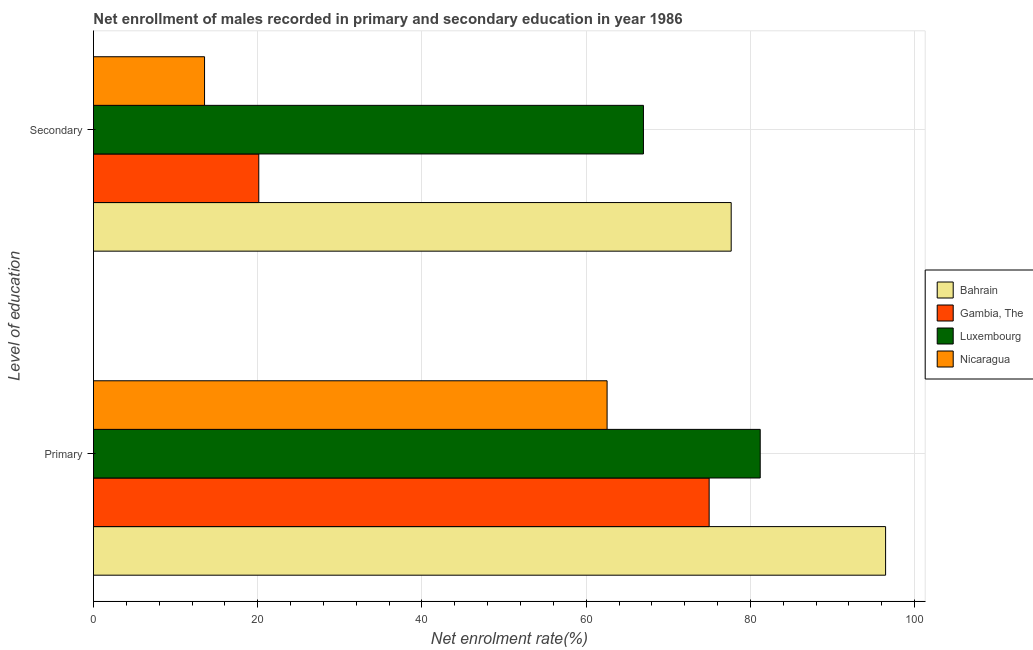How many different coloured bars are there?
Provide a succinct answer. 4. How many groups of bars are there?
Keep it short and to the point. 2. Are the number of bars per tick equal to the number of legend labels?
Your response must be concise. Yes. Are the number of bars on each tick of the Y-axis equal?
Offer a terse response. Yes. What is the label of the 1st group of bars from the top?
Give a very brief answer. Secondary. What is the enrollment rate in secondary education in Nicaragua?
Give a very brief answer. 13.53. Across all countries, what is the maximum enrollment rate in secondary education?
Your answer should be very brief. 77.66. Across all countries, what is the minimum enrollment rate in primary education?
Your answer should be compact. 62.55. In which country was the enrollment rate in primary education maximum?
Keep it short and to the point. Bahrain. In which country was the enrollment rate in primary education minimum?
Provide a succinct answer. Nicaragua. What is the total enrollment rate in primary education in the graph?
Offer a terse response. 315.2. What is the difference between the enrollment rate in primary education in Nicaragua and that in Bahrain?
Make the answer very short. -33.92. What is the difference between the enrollment rate in secondary education in Bahrain and the enrollment rate in primary education in Nicaragua?
Offer a terse response. 15.11. What is the average enrollment rate in primary education per country?
Provide a short and direct response. 78.8. What is the difference between the enrollment rate in primary education and enrollment rate in secondary education in Bahrain?
Provide a short and direct response. 18.8. What is the ratio of the enrollment rate in secondary education in Luxembourg to that in Nicaragua?
Your answer should be compact. 4.95. In how many countries, is the enrollment rate in secondary education greater than the average enrollment rate in secondary education taken over all countries?
Your answer should be compact. 2. What does the 2nd bar from the top in Secondary represents?
Ensure brevity in your answer.  Luxembourg. What does the 3rd bar from the bottom in Secondary represents?
Give a very brief answer. Luxembourg. What is the difference between two consecutive major ticks on the X-axis?
Provide a succinct answer. 20. Where does the legend appear in the graph?
Keep it short and to the point. Center right. How many legend labels are there?
Ensure brevity in your answer.  4. What is the title of the graph?
Ensure brevity in your answer.  Net enrollment of males recorded in primary and secondary education in year 1986. Does "Micronesia" appear as one of the legend labels in the graph?
Your response must be concise. No. What is the label or title of the X-axis?
Offer a terse response. Net enrolment rate(%). What is the label or title of the Y-axis?
Provide a short and direct response. Level of education. What is the Net enrolment rate(%) in Bahrain in Primary?
Ensure brevity in your answer.  96.47. What is the Net enrolment rate(%) of Gambia, The in Primary?
Make the answer very short. 74.98. What is the Net enrolment rate(%) of Luxembourg in Primary?
Your answer should be very brief. 81.2. What is the Net enrolment rate(%) of Nicaragua in Primary?
Offer a very short reply. 62.55. What is the Net enrolment rate(%) of Bahrain in Secondary?
Your answer should be very brief. 77.66. What is the Net enrolment rate(%) in Gambia, The in Secondary?
Give a very brief answer. 20.13. What is the Net enrolment rate(%) in Luxembourg in Secondary?
Offer a very short reply. 66.98. What is the Net enrolment rate(%) of Nicaragua in Secondary?
Your response must be concise. 13.53. Across all Level of education, what is the maximum Net enrolment rate(%) of Bahrain?
Make the answer very short. 96.47. Across all Level of education, what is the maximum Net enrolment rate(%) in Gambia, The?
Your answer should be very brief. 74.98. Across all Level of education, what is the maximum Net enrolment rate(%) of Luxembourg?
Your answer should be compact. 81.2. Across all Level of education, what is the maximum Net enrolment rate(%) of Nicaragua?
Provide a succinct answer. 62.55. Across all Level of education, what is the minimum Net enrolment rate(%) of Bahrain?
Offer a terse response. 77.66. Across all Level of education, what is the minimum Net enrolment rate(%) in Gambia, The?
Your answer should be compact. 20.13. Across all Level of education, what is the minimum Net enrolment rate(%) in Luxembourg?
Keep it short and to the point. 66.98. Across all Level of education, what is the minimum Net enrolment rate(%) of Nicaragua?
Your response must be concise. 13.53. What is the total Net enrolment rate(%) of Bahrain in the graph?
Offer a very short reply. 174.13. What is the total Net enrolment rate(%) in Gambia, The in the graph?
Your answer should be very brief. 95.11. What is the total Net enrolment rate(%) in Luxembourg in the graph?
Offer a very short reply. 148.18. What is the total Net enrolment rate(%) of Nicaragua in the graph?
Ensure brevity in your answer.  76.08. What is the difference between the Net enrolment rate(%) of Bahrain in Primary and that in Secondary?
Make the answer very short. 18.8. What is the difference between the Net enrolment rate(%) in Gambia, The in Primary and that in Secondary?
Ensure brevity in your answer.  54.85. What is the difference between the Net enrolment rate(%) of Luxembourg in Primary and that in Secondary?
Provide a succinct answer. 14.22. What is the difference between the Net enrolment rate(%) of Nicaragua in Primary and that in Secondary?
Keep it short and to the point. 49.02. What is the difference between the Net enrolment rate(%) of Bahrain in Primary and the Net enrolment rate(%) of Gambia, The in Secondary?
Provide a short and direct response. 76.33. What is the difference between the Net enrolment rate(%) in Bahrain in Primary and the Net enrolment rate(%) in Luxembourg in Secondary?
Offer a very short reply. 29.49. What is the difference between the Net enrolment rate(%) of Bahrain in Primary and the Net enrolment rate(%) of Nicaragua in Secondary?
Give a very brief answer. 82.94. What is the difference between the Net enrolment rate(%) in Gambia, The in Primary and the Net enrolment rate(%) in Luxembourg in Secondary?
Your answer should be very brief. 8. What is the difference between the Net enrolment rate(%) of Gambia, The in Primary and the Net enrolment rate(%) of Nicaragua in Secondary?
Give a very brief answer. 61.45. What is the difference between the Net enrolment rate(%) in Luxembourg in Primary and the Net enrolment rate(%) in Nicaragua in Secondary?
Offer a terse response. 67.67. What is the average Net enrolment rate(%) of Bahrain per Level of education?
Give a very brief answer. 87.06. What is the average Net enrolment rate(%) of Gambia, The per Level of education?
Your answer should be compact. 47.56. What is the average Net enrolment rate(%) in Luxembourg per Level of education?
Offer a very short reply. 74.09. What is the average Net enrolment rate(%) in Nicaragua per Level of education?
Your response must be concise. 38.04. What is the difference between the Net enrolment rate(%) of Bahrain and Net enrolment rate(%) of Gambia, The in Primary?
Your answer should be compact. 21.49. What is the difference between the Net enrolment rate(%) of Bahrain and Net enrolment rate(%) of Luxembourg in Primary?
Give a very brief answer. 15.27. What is the difference between the Net enrolment rate(%) of Bahrain and Net enrolment rate(%) of Nicaragua in Primary?
Your answer should be very brief. 33.92. What is the difference between the Net enrolment rate(%) of Gambia, The and Net enrolment rate(%) of Luxembourg in Primary?
Make the answer very short. -6.22. What is the difference between the Net enrolment rate(%) in Gambia, The and Net enrolment rate(%) in Nicaragua in Primary?
Provide a succinct answer. 12.43. What is the difference between the Net enrolment rate(%) of Luxembourg and Net enrolment rate(%) of Nicaragua in Primary?
Provide a short and direct response. 18.65. What is the difference between the Net enrolment rate(%) of Bahrain and Net enrolment rate(%) of Gambia, The in Secondary?
Make the answer very short. 57.53. What is the difference between the Net enrolment rate(%) in Bahrain and Net enrolment rate(%) in Luxembourg in Secondary?
Give a very brief answer. 10.69. What is the difference between the Net enrolment rate(%) of Bahrain and Net enrolment rate(%) of Nicaragua in Secondary?
Give a very brief answer. 64.14. What is the difference between the Net enrolment rate(%) of Gambia, The and Net enrolment rate(%) of Luxembourg in Secondary?
Make the answer very short. -46.85. What is the difference between the Net enrolment rate(%) in Gambia, The and Net enrolment rate(%) in Nicaragua in Secondary?
Provide a short and direct response. 6.61. What is the difference between the Net enrolment rate(%) of Luxembourg and Net enrolment rate(%) of Nicaragua in Secondary?
Your answer should be compact. 53.45. What is the ratio of the Net enrolment rate(%) in Bahrain in Primary to that in Secondary?
Your answer should be very brief. 1.24. What is the ratio of the Net enrolment rate(%) of Gambia, The in Primary to that in Secondary?
Give a very brief answer. 3.72. What is the ratio of the Net enrolment rate(%) of Luxembourg in Primary to that in Secondary?
Provide a short and direct response. 1.21. What is the ratio of the Net enrolment rate(%) of Nicaragua in Primary to that in Secondary?
Ensure brevity in your answer.  4.62. What is the difference between the highest and the second highest Net enrolment rate(%) in Bahrain?
Your answer should be very brief. 18.8. What is the difference between the highest and the second highest Net enrolment rate(%) of Gambia, The?
Your answer should be compact. 54.85. What is the difference between the highest and the second highest Net enrolment rate(%) in Luxembourg?
Make the answer very short. 14.22. What is the difference between the highest and the second highest Net enrolment rate(%) in Nicaragua?
Provide a succinct answer. 49.02. What is the difference between the highest and the lowest Net enrolment rate(%) in Bahrain?
Offer a very short reply. 18.8. What is the difference between the highest and the lowest Net enrolment rate(%) of Gambia, The?
Keep it short and to the point. 54.85. What is the difference between the highest and the lowest Net enrolment rate(%) in Luxembourg?
Your answer should be very brief. 14.22. What is the difference between the highest and the lowest Net enrolment rate(%) in Nicaragua?
Your response must be concise. 49.02. 